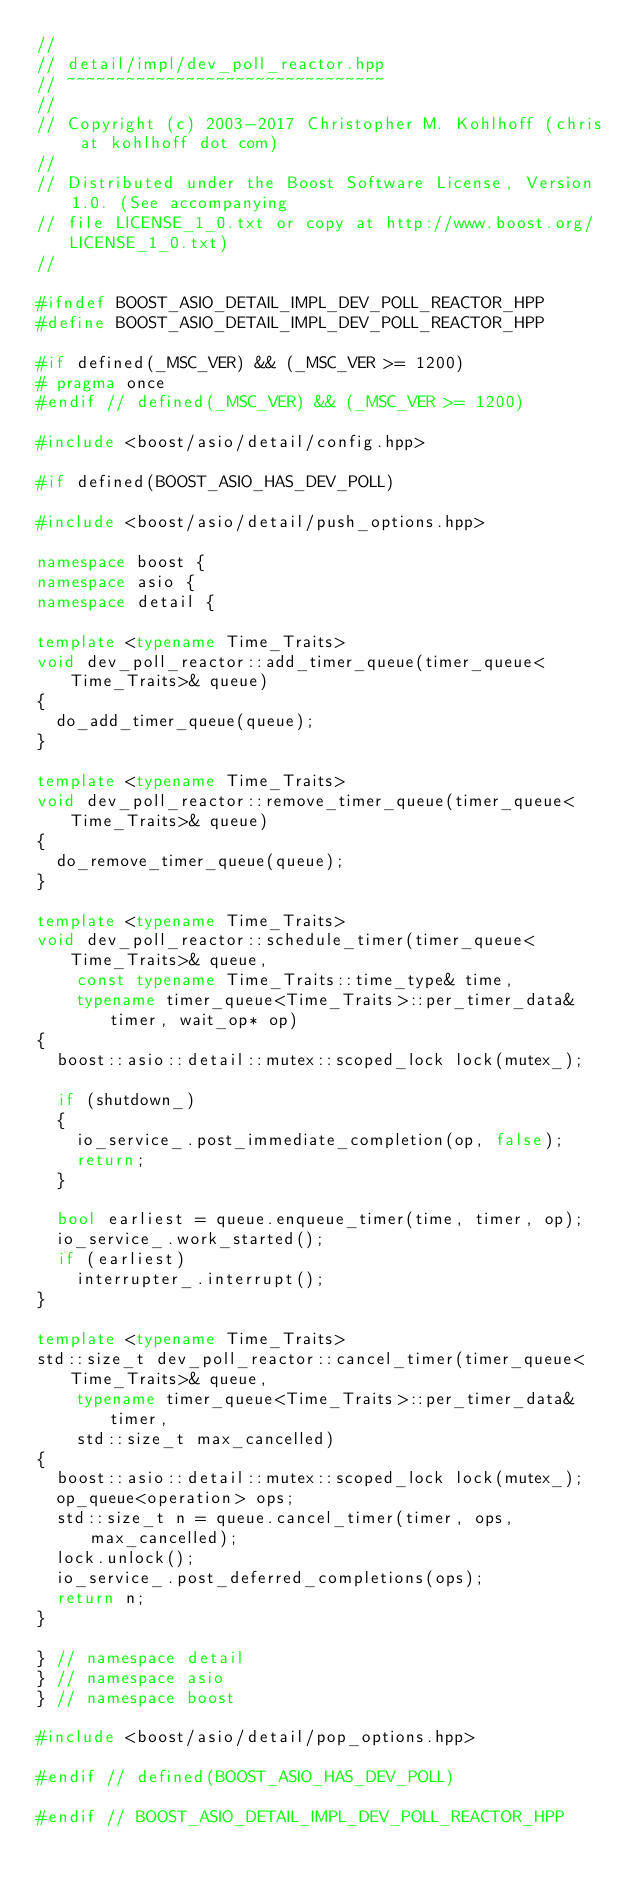Convert code to text. <code><loc_0><loc_0><loc_500><loc_500><_C++_>//
// detail/impl/dev_poll_reactor.hpp
// ~~~~~~~~~~~~~~~~~~~~~~~~~~~~~~~~
//
// Copyright (c) 2003-2017 Christopher M. Kohlhoff (chris at kohlhoff dot com)
//
// Distributed under the Boost Software License, Version 1.0. (See accompanying
// file LICENSE_1_0.txt or copy at http://www.boost.org/LICENSE_1_0.txt)
//

#ifndef BOOST_ASIO_DETAIL_IMPL_DEV_POLL_REACTOR_HPP
#define BOOST_ASIO_DETAIL_IMPL_DEV_POLL_REACTOR_HPP

#if defined(_MSC_VER) && (_MSC_VER >= 1200)
# pragma once
#endif // defined(_MSC_VER) && (_MSC_VER >= 1200)

#include <boost/asio/detail/config.hpp>

#if defined(BOOST_ASIO_HAS_DEV_POLL)

#include <boost/asio/detail/push_options.hpp>

namespace boost {
namespace asio {
namespace detail {

template <typename Time_Traits>
void dev_poll_reactor::add_timer_queue(timer_queue<Time_Traits>& queue)
{
  do_add_timer_queue(queue);
}

template <typename Time_Traits>
void dev_poll_reactor::remove_timer_queue(timer_queue<Time_Traits>& queue)
{
  do_remove_timer_queue(queue);
}

template <typename Time_Traits>
void dev_poll_reactor::schedule_timer(timer_queue<Time_Traits>& queue,
    const typename Time_Traits::time_type& time,
    typename timer_queue<Time_Traits>::per_timer_data& timer, wait_op* op)
{
  boost::asio::detail::mutex::scoped_lock lock(mutex_);

  if (shutdown_)
  {
    io_service_.post_immediate_completion(op, false);
    return;
  }

  bool earliest = queue.enqueue_timer(time, timer, op);
  io_service_.work_started();
  if (earliest)
    interrupter_.interrupt();
}

template <typename Time_Traits>
std::size_t dev_poll_reactor::cancel_timer(timer_queue<Time_Traits>& queue,
    typename timer_queue<Time_Traits>::per_timer_data& timer,
    std::size_t max_cancelled)
{
  boost::asio::detail::mutex::scoped_lock lock(mutex_);
  op_queue<operation> ops;
  std::size_t n = queue.cancel_timer(timer, ops, max_cancelled);
  lock.unlock();
  io_service_.post_deferred_completions(ops);
  return n;
}

} // namespace detail
} // namespace asio
} // namespace boost

#include <boost/asio/detail/pop_options.hpp>

#endif // defined(BOOST_ASIO_HAS_DEV_POLL)

#endif // BOOST_ASIO_DETAIL_IMPL_DEV_POLL_REACTOR_HPP
</code> 